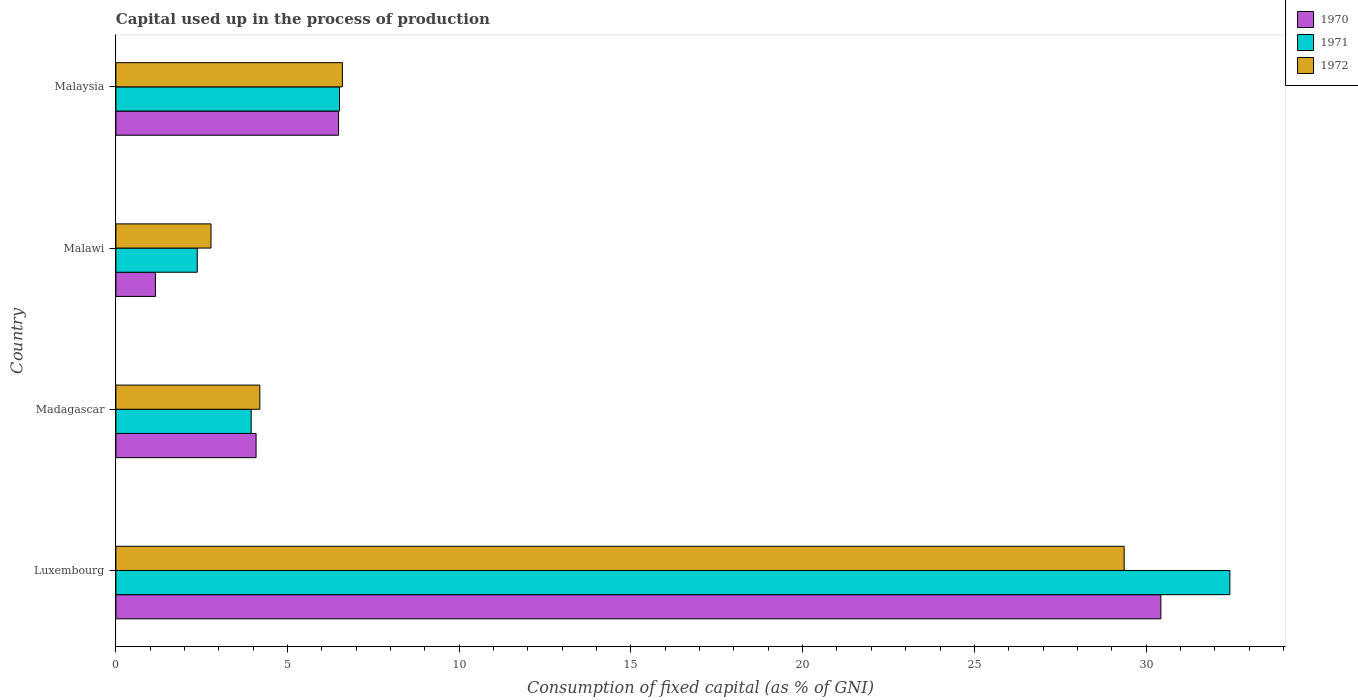How many different coloured bars are there?
Ensure brevity in your answer.  3. How many groups of bars are there?
Ensure brevity in your answer.  4. Are the number of bars per tick equal to the number of legend labels?
Offer a terse response. Yes. Are the number of bars on each tick of the Y-axis equal?
Keep it short and to the point. Yes. How many bars are there on the 4th tick from the top?
Give a very brief answer. 3. What is the label of the 3rd group of bars from the top?
Offer a terse response. Madagascar. In how many cases, is the number of bars for a given country not equal to the number of legend labels?
Your answer should be compact. 0. What is the capital used up in the process of production in 1970 in Malawi?
Your answer should be very brief. 1.15. Across all countries, what is the maximum capital used up in the process of production in 1971?
Provide a succinct answer. 32.44. Across all countries, what is the minimum capital used up in the process of production in 1971?
Your response must be concise. 2.37. In which country was the capital used up in the process of production in 1971 maximum?
Your answer should be compact. Luxembourg. In which country was the capital used up in the process of production in 1972 minimum?
Provide a short and direct response. Malawi. What is the total capital used up in the process of production in 1970 in the graph?
Ensure brevity in your answer.  42.15. What is the difference between the capital used up in the process of production in 1972 in Madagascar and that in Malawi?
Offer a very short reply. 1.42. What is the difference between the capital used up in the process of production in 1970 in Malawi and the capital used up in the process of production in 1972 in Luxembourg?
Keep it short and to the point. -28.21. What is the average capital used up in the process of production in 1972 per country?
Give a very brief answer. 10.73. What is the difference between the capital used up in the process of production in 1971 and capital used up in the process of production in 1972 in Malaysia?
Offer a very short reply. -0.08. What is the ratio of the capital used up in the process of production in 1972 in Malawi to that in Malaysia?
Offer a terse response. 0.42. Is the difference between the capital used up in the process of production in 1971 in Malawi and Malaysia greater than the difference between the capital used up in the process of production in 1972 in Malawi and Malaysia?
Your answer should be very brief. No. What is the difference between the highest and the second highest capital used up in the process of production in 1970?
Keep it short and to the point. 23.95. What is the difference between the highest and the lowest capital used up in the process of production in 1970?
Your answer should be compact. 29.28. Are all the bars in the graph horizontal?
Ensure brevity in your answer.  Yes. How many countries are there in the graph?
Your answer should be compact. 4. What is the difference between two consecutive major ticks on the X-axis?
Keep it short and to the point. 5. Does the graph contain any zero values?
Offer a very short reply. No. Does the graph contain grids?
Provide a succinct answer. No. How many legend labels are there?
Your response must be concise. 3. What is the title of the graph?
Give a very brief answer. Capital used up in the process of production. Does "1991" appear as one of the legend labels in the graph?
Offer a terse response. No. What is the label or title of the X-axis?
Provide a short and direct response. Consumption of fixed capital (as % of GNI). What is the Consumption of fixed capital (as % of GNI) in 1970 in Luxembourg?
Your answer should be compact. 30.43. What is the Consumption of fixed capital (as % of GNI) in 1971 in Luxembourg?
Provide a succinct answer. 32.44. What is the Consumption of fixed capital (as % of GNI) in 1972 in Luxembourg?
Offer a very short reply. 29.36. What is the Consumption of fixed capital (as % of GNI) in 1970 in Madagascar?
Provide a short and direct response. 4.08. What is the Consumption of fixed capital (as % of GNI) in 1971 in Madagascar?
Offer a terse response. 3.94. What is the Consumption of fixed capital (as % of GNI) of 1972 in Madagascar?
Your response must be concise. 4.19. What is the Consumption of fixed capital (as % of GNI) of 1970 in Malawi?
Offer a very short reply. 1.15. What is the Consumption of fixed capital (as % of GNI) of 1971 in Malawi?
Your response must be concise. 2.37. What is the Consumption of fixed capital (as % of GNI) in 1972 in Malawi?
Your answer should be compact. 2.77. What is the Consumption of fixed capital (as % of GNI) of 1970 in Malaysia?
Your answer should be compact. 6.48. What is the Consumption of fixed capital (as % of GNI) of 1971 in Malaysia?
Provide a short and direct response. 6.51. What is the Consumption of fixed capital (as % of GNI) in 1972 in Malaysia?
Give a very brief answer. 6.6. Across all countries, what is the maximum Consumption of fixed capital (as % of GNI) in 1970?
Make the answer very short. 30.43. Across all countries, what is the maximum Consumption of fixed capital (as % of GNI) in 1971?
Give a very brief answer. 32.44. Across all countries, what is the maximum Consumption of fixed capital (as % of GNI) of 1972?
Offer a terse response. 29.36. Across all countries, what is the minimum Consumption of fixed capital (as % of GNI) in 1970?
Your answer should be very brief. 1.15. Across all countries, what is the minimum Consumption of fixed capital (as % of GNI) in 1971?
Give a very brief answer. 2.37. Across all countries, what is the minimum Consumption of fixed capital (as % of GNI) of 1972?
Your answer should be very brief. 2.77. What is the total Consumption of fixed capital (as % of GNI) in 1970 in the graph?
Offer a very short reply. 42.15. What is the total Consumption of fixed capital (as % of GNI) in 1971 in the graph?
Give a very brief answer. 45.26. What is the total Consumption of fixed capital (as % of GNI) of 1972 in the graph?
Offer a terse response. 42.92. What is the difference between the Consumption of fixed capital (as % of GNI) in 1970 in Luxembourg and that in Madagascar?
Provide a short and direct response. 26.35. What is the difference between the Consumption of fixed capital (as % of GNI) in 1971 in Luxembourg and that in Madagascar?
Make the answer very short. 28.5. What is the difference between the Consumption of fixed capital (as % of GNI) of 1972 in Luxembourg and that in Madagascar?
Offer a terse response. 25.17. What is the difference between the Consumption of fixed capital (as % of GNI) in 1970 in Luxembourg and that in Malawi?
Give a very brief answer. 29.28. What is the difference between the Consumption of fixed capital (as % of GNI) of 1971 in Luxembourg and that in Malawi?
Your response must be concise. 30.07. What is the difference between the Consumption of fixed capital (as % of GNI) of 1972 in Luxembourg and that in Malawi?
Your answer should be compact. 26.59. What is the difference between the Consumption of fixed capital (as % of GNI) of 1970 in Luxembourg and that in Malaysia?
Your answer should be compact. 23.95. What is the difference between the Consumption of fixed capital (as % of GNI) in 1971 in Luxembourg and that in Malaysia?
Ensure brevity in your answer.  25.93. What is the difference between the Consumption of fixed capital (as % of GNI) of 1972 in Luxembourg and that in Malaysia?
Your answer should be very brief. 22.77. What is the difference between the Consumption of fixed capital (as % of GNI) of 1970 in Madagascar and that in Malawi?
Your answer should be very brief. 2.93. What is the difference between the Consumption of fixed capital (as % of GNI) in 1971 in Madagascar and that in Malawi?
Your response must be concise. 1.57. What is the difference between the Consumption of fixed capital (as % of GNI) in 1972 in Madagascar and that in Malawi?
Your answer should be very brief. 1.42. What is the difference between the Consumption of fixed capital (as % of GNI) of 1970 in Madagascar and that in Malaysia?
Your answer should be very brief. -2.4. What is the difference between the Consumption of fixed capital (as % of GNI) of 1971 in Madagascar and that in Malaysia?
Make the answer very short. -2.57. What is the difference between the Consumption of fixed capital (as % of GNI) in 1972 in Madagascar and that in Malaysia?
Give a very brief answer. -2.4. What is the difference between the Consumption of fixed capital (as % of GNI) in 1970 in Malawi and that in Malaysia?
Offer a very short reply. -5.33. What is the difference between the Consumption of fixed capital (as % of GNI) in 1971 in Malawi and that in Malaysia?
Give a very brief answer. -4.14. What is the difference between the Consumption of fixed capital (as % of GNI) in 1972 in Malawi and that in Malaysia?
Offer a very short reply. -3.82. What is the difference between the Consumption of fixed capital (as % of GNI) of 1970 in Luxembourg and the Consumption of fixed capital (as % of GNI) of 1971 in Madagascar?
Your response must be concise. 26.49. What is the difference between the Consumption of fixed capital (as % of GNI) of 1970 in Luxembourg and the Consumption of fixed capital (as % of GNI) of 1972 in Madagascar?
Provide a short and direct response. 26.24. What is the difference between the Consumption of fixed capital (as % of GNI) in 1971 in Luxembourg and the Consumption of fixed capital (as % of GNI) in 1972 in Madagascar?
Offer a very short reply. 28.25. What is the difference between the Consumption of fixed capital (as % of GNI) of 1970 in Luxembourg and the Consumption of fixed capital (as % of GNI) of 1971 in Malawi?
Your response must be concise. 28.06. What is the difference between the Consumption of fixed capital (as % of GNI) of 1970 in Luxembourg and the Consumption of fixed capital (as % of GNI) of 1972 in Malawi?
Offer a very short reply. 27.66. What is the difference between the Consumption of fixed capital (as % of GNI) in 1971 in Luxembourg and the Consumption of fixed capital (as % of GNI) in 1972 in Malawi?
Your answer should be very brief. 29.67. What is the difference between the Consumption of fixed capital (as % of GNI) in 1970 in Luxembourg and the Consumption of fixed capital (as % of GNI) in 1971 in Malaysia?
Provide a short and direct response. 23.92. What is the difference between the Consumption of fixed capital (as % of GNI) in 1970 in Luxembourg and the Consumption of fixed capital (as % of GNI) in 1972 in Malaysia?
Ensure brevity in your answer.  23.84. What is the difference between the Consumption of fixed capital (as % of GNI) in 1971 in Luxembourg and the Consumption of fixed capital (as % of GNI) in 1972 in Malaysia?
Your answer should be very brief. 25.85. What is the difference between the Consumption of fixed capital (as % of GNI) in 1970 in Madagascar and the Consumption of fixed capital (as % of GNI) in 1971 in Malawi?
Make the answer very short. 1.71. What is the difference between the Consumption of fixed capital (as % of GNI) in 1970 in Madagascar and the Consumption of fixed capital (as % of GNI) in 1972 in Malawi?
Offer a very short reply. 1.31. What is the difference between the Consumption of fixed capital (as % of GNI) of 1971 in Madagascar and the Consumption of fixed capital (as % of GNI) of 1972 in Malawi?
Your response must be concise. 1.17. What is the difference between the Consumption of fixed capital (as % of GNI) in 1970 in Madagascar and the Consumption of fixed capital (as % of GNI) in 1971 in Malaysia?
Make the answer very short. -2.43. What is the difference between the Consumption of fixed capital (as % of GNI) in 1970 in Madagascar and the Consumption of fixed capital (as % of GNI) in 1972 in Malaysia?
Offer a very short reply. -2.51. What is the difference between the Consumption of fixed capital (as % of GNI) of 1971 in Madagascar and the Consumption of fixed capital (as % of GNI) of 1972 in Malaysia?
Your response must be concise. -2.65. What is the difference between the Consumption of fixed capital (as % of GNI) of 1970 in Malawi and the Consumption of fixed capital (as % of GNI) of 1971 in Malaysia?
Give a very brief answer. -5.36. What is the difference between the Consumption of fixed capital (as % of GNI) in 1970 in Malawi and the Consumption of fixed capital (as % of GNI) in 1972 in Malaysia?
Make the answer very short. -5.44. What is the difference between the Consumption of fixed capital (as % of GNI) in 1971 in Malawi and the Consumption of fixed capital (as % of GNI) in 1972 in Malaysia?
Your answer should be compact. -4.23. What is the average Consumption of fixed capital (as % of GNI) in 1970 per country?
Offer a very short reply. 10.54. What is the average Consumption of fixed capital (as % of GNI) of 1971 per country?
Make the answer very short. 11.32. What is the average Consumption of fixed capital (as % of GNI) in 1972 per country?
Your answer should be very brief. 10.73. What is the difference between the Consumption of fixed capital (as % of GNI) in 1970 and Consumption of fixed capital (as % of GNI) in 1971 in Luxembourg?
Provide a succinct answer. -2.01. What is the difference between the Consumption of fixed capital (as % of GNI) in 1970 and Consumption of fixed capital (as % of GNI) in 1972 in Luxembourg?
Provide a short and direct response. 1.07. What is the difference between the Consumption of fixed capital (as % of GNI) of 1971 and Consumption of fixed capital (as % of GNI) of 1972 in Luxembourg?
Your response must be concise. 3.08. What is the difference between the Consumption of fixed capital (as % of GNI) of 1970 and Consumption of fixed capital (as % of GNI) of 1971 in Madagascar?
Give a very brief answer. 0.14. What is the difference between the Consumption of fixed capital (as % of GNI) in 1970 and Consumption of fixed capital (as % of GNI) in 1972 in Madagascar?
Your answer should be compact. -0.11. What is the difference between the Consumption of fixed capital (as % of GNI) of 1971 and Consumption of fixed capital (as % of GNI) of 1972 in Madagascar?
Provide a short and direct response. -0.25. What is the difference between the Consumption of fixed capital (as % of GNI) in 1970 and Consumption of fixed capital (as % of GNI) in 1971 in Malawi?
Offer a very short reply. -1.22. What is the difference between the Consumption of fixed capital (as % of GNI) of 1970 and Consumption of fixed capital (as % of GNI) of 1972 in Malawi?
Provide a succinct answer. -1.62. What is the difference between the Consumption of fixed capital (as % of GNI) in 1971 and Consumption of fixed capital (as % of GNI) in 1972 in Malawi?
Your answer should be compact. -0.4. What is the difference between the Consumption of fixed capital (as % of GNI) of 1970 and Consumption of fixed capital (as % of GNI) of 1971 in Malaysia?
Offer a terse response. -0.03. What is the difference between the Consumption of fixed capital (as % of GNI) of 1970 and Consumption of fixed capital (as % of GNI) of 1972 in Malaysia?
Your response must be concise. -0.11. What is the difference between the Consumption of fixed capital (as % of GNI) of 1971 and Consumption of fixed capital (as % of GNI) of 1972 in Malaysia?
Your answer should be very brief. -0.08. What is the ratio of the Consumption of fixed capital (as % of GNI) of 1970 in Luxembourg to that in Madagascar?
Offer a very short reply. 7.45. What is the ratio of the Consumption of fixed capital (as % of GNI) of 1971 in Luxembourg to that in Madagascar?
Offer a terse response. 8.23. What is the ratio of the Consumption of fixed capital (as % of GNI) in 1972 in Luxembourg to that in Madagascar?
Offer a very short reply. 7. What is the ratio of the Consumption of fixed capital (as % of GNI) of 1970 in Luxembourg to that in Malawi?
Ensure brevity in your answer.  26.44. What is the ratio of the Consumption of fixed capital (as % of GNI) of 1971 in Luxembourg to that in Malawi?
Give a very brief answer. 13.69. What is the ratio of the Consumption of fixed capital (as % of GNI) in 1972 in Luxembourg to that in Malawi?
Ensure brevity in your answer.  10.6. What is the ratio of the Consumption of fixed capital (as % of GNI) in 1970 in Luxembourg to that in Malaysia?
Make the answer very short. 4.69. What is the ratio of the Consumption of fixed capital (as % of GNI) of 1971 in Luxembourg to that in Malaysia?
Provide a succinct answer. 4.98. What is the ratio of the Consumption of fixed capital (as % of GNI) of 1972 in Luxembourg to that in Malaysia?
Keep it short and to the point. 4.45. What is the ratio of the Consumption of fixed capital (as % of GNI) of 1970 in Madagascar to that in Malawi?
Your answer should be very brief. 3.55. What is the ratio of the Consumption of fixed capital (as % of GNI) in 1971 in Madagascar to that in Malawi?
Offer a terse response. 1.66. What is the ratio of the Consumption of fixed capital (as % of GNI) in 1972 in Madagascar to that in Malawi?
Provide a short and direct response. 1.51. What is the ratio of the Consumption of fixed capital (as % of GNI) of 1970 in Madagascar to that in Malaysia?
Offer a very short reply. 0.63. What is the ratio of the Consumption of fixed capital (as % of GNI) of 1971 in Madagascar to that in Malaysia?
Your answer should be very brief. 0.61. What is the ratio of the Consumption of fixed capital (as % of GNI) of 1972 in Madagascar to that in Malaysia?
Keep it short and to the point. 0.64. What is the ratio of the Consumption of fixed capital (as % of GNI) in 1970 in Malawi to that in Malaysia?
Give a very brief answer. 0.18. What is the ratio of the Consumption of fixed capital (as % of GNI) of 1971 in Malawi to that in Malaysia?
Make the answer very short. 0.36. What is the ratio of the Consumption of fixed capital (as % of GNI) of 1972 in Malawi to that in Malaysia?
Keep it short and to the point. 0.42. What is the difference between the highest and the second highest Consumption of fixed capital (as % of GNI) in 1970?
Offer a very short reply. 23.95. What is the difference between the highest and the second highest Consumption of fixed capital (as % of GNI) of 1971?
Make the answer very short. 25.93. What is the difference between the highest and the second highest Consumption of fixed capital (as % of GNI) in 1972?
Give a very brief answer. 22.77. What is the difference between the highest and the lowest Consumption of fixed capital (as % of GNI) of 1970?
Your answer should be very brief. 29.28. What is the difference between the highest and the lowest Consumption of fixed capital (as % of GNI) of 1971?
Give a very brief answer. 30.07. What is the difference between the highest and the lowest Consumption of fixed capital (as % of GNI) of 1972?
Ensure brevity in your answer.  26.59. 